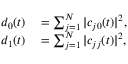<formula> <loc_0><loc_0><loc_500><loc_500>\begin{array} { r l } { d _ { 0 } ( t ) } & = \sum _ { j = 1 } ^ { N } | c _ { j 0 } ( t ) | ^ { 2 } , } \\ { d _ { 1 } ( t ) } & = \sum _ { j = 1 } ^ { N } | c _ { j j } ( t ) | ^ { 2 } , } \end{array}</formula> 